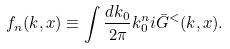<formula> <loc_0><loc_0><loc_500><loc_500>f _ { n } ( k , x ) \equiv \int \frac { d k _ { 0 } } { 2 \pi } k ^ { n } _ { 0 } i \bar { G } ^ { < } ( k , x ) .</formula> 